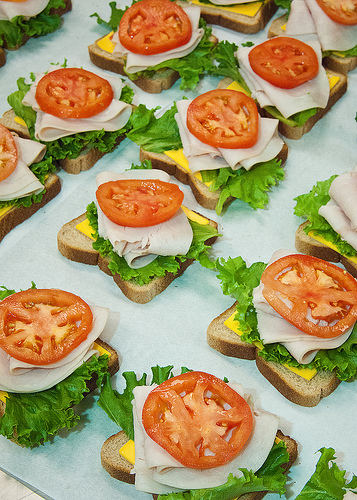<image>
Is there a tomato on the bread? No. The tomato is not positioned on the bread. They may be near each other, but the tomato is not supported by or resting on top of the bread. 